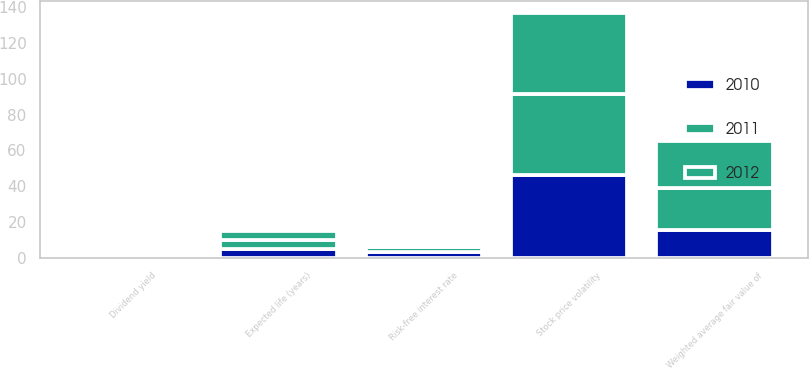Convert chart to OTSL. <chart><loc_0><loc_0><loc_500><loc_500><stacked_bar_chart><ecel><fcel>Dividend yield<fcel>Risk-free interest rate<fcel>Stock price volatility<fcel>Expected life (years)<fcel>Weighted average fair value of<nl><fcel>2012<fcel>0.23<fcel>1.4<fcel>45<fcel>5<fcel>26.42<nl><fcel>2011<fcel>0.08<fcel>3<fcel>45.6<fcel>5<fcel>23.2<nl><fcel>2010<fcel>0.1<fcel>3.2<fcel>46.1<fcel>5<fcel>15.69<nl></chart> 